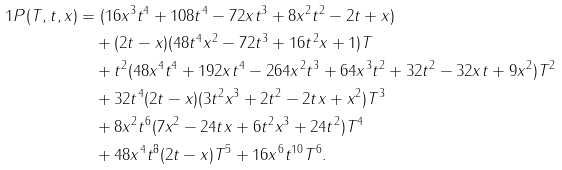<formula> <loc_0><loc_0><loc_500><loc_500>1 P ( T , t , x ) & = ( 1 6 x ^ { 3 } t ^ { 4 } + 1 0 8 t ^ { 4 } - 7 2 x t ^ { 3 } + 8 x ^ { 2 } t ^ { 2 } - 2 t + x ) \\ & \quad + ( 2 t - x ) ( 4 8 t ^ { 4 } x ^ { 2 } - 7 2 t ^ { 3 } + 1 6 t ^ { 2 } x + 1 ) T \\ & \quad + t ^ { 2 } ( 4 8 x ^ { 4 } t ^ { 4 } + 1 9 2 x t ^ { 4 } - 2 6 4 x ^ { 2 } t ^ { 3 } + 6 4 x ^ { 3 } t ^ { 2 } + 3 2 t ^ { 2 } - 3 2 x t + 9 x ^ { 2 } ) T ^ { 2 } \\ & \quad + 3 2 t ^ { 4 } ( 2 t - x ) ( 3 t ^ { 2 } x ^ { 3 } + 2 t ^ { 2 } - 2 t x + x ^ { 2 } ) T ^ { 3 } \\ & \quad + 8 x ^ { 2 } t ^ { 6 } ( 7 x ^ { 2 } - 2 4 t x + 6 t ^ { 2 } x ^ { 3 } + 2 4 t ^ { 2 } ) T ^ { 4 } \\ & \quad + 4 8 x ^ { 4 } t ^ { 8 } ( 2 t - x ) T ^ { 5 } + 1 6 x ^ { 6 } t ^ { 1 0 } T ^ { 6 } .</formula> 